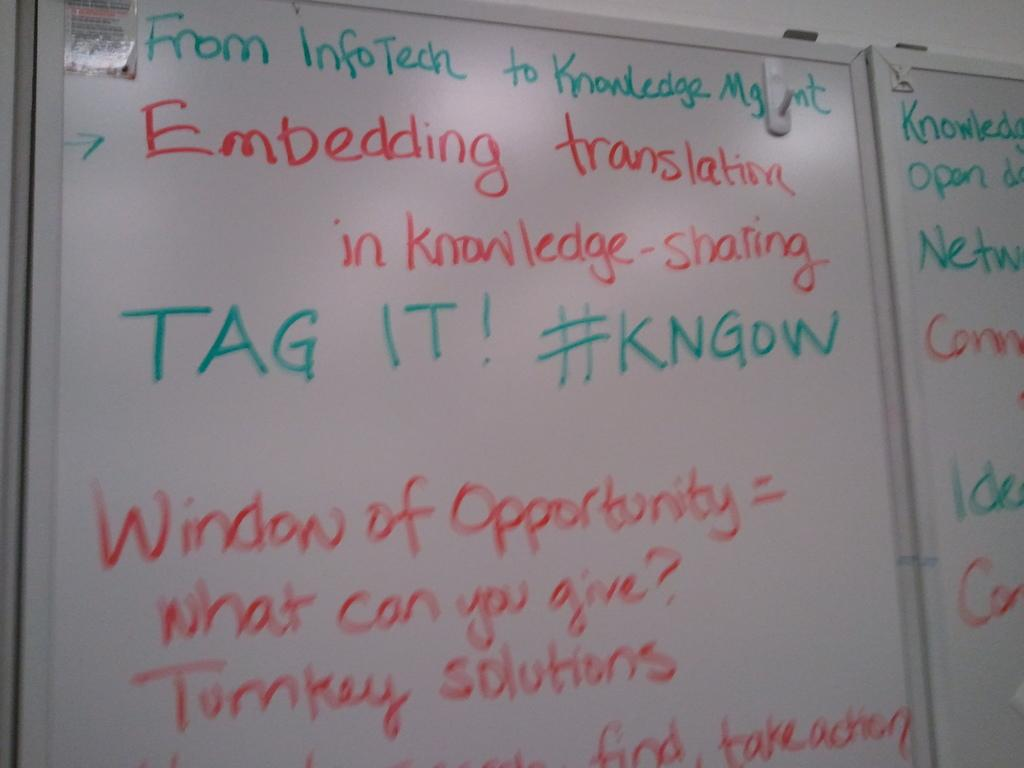Provide a one-sentence caption for the provided image. A white board written in red and green markers stating From InfoTech to Knowledge Mgmt. 